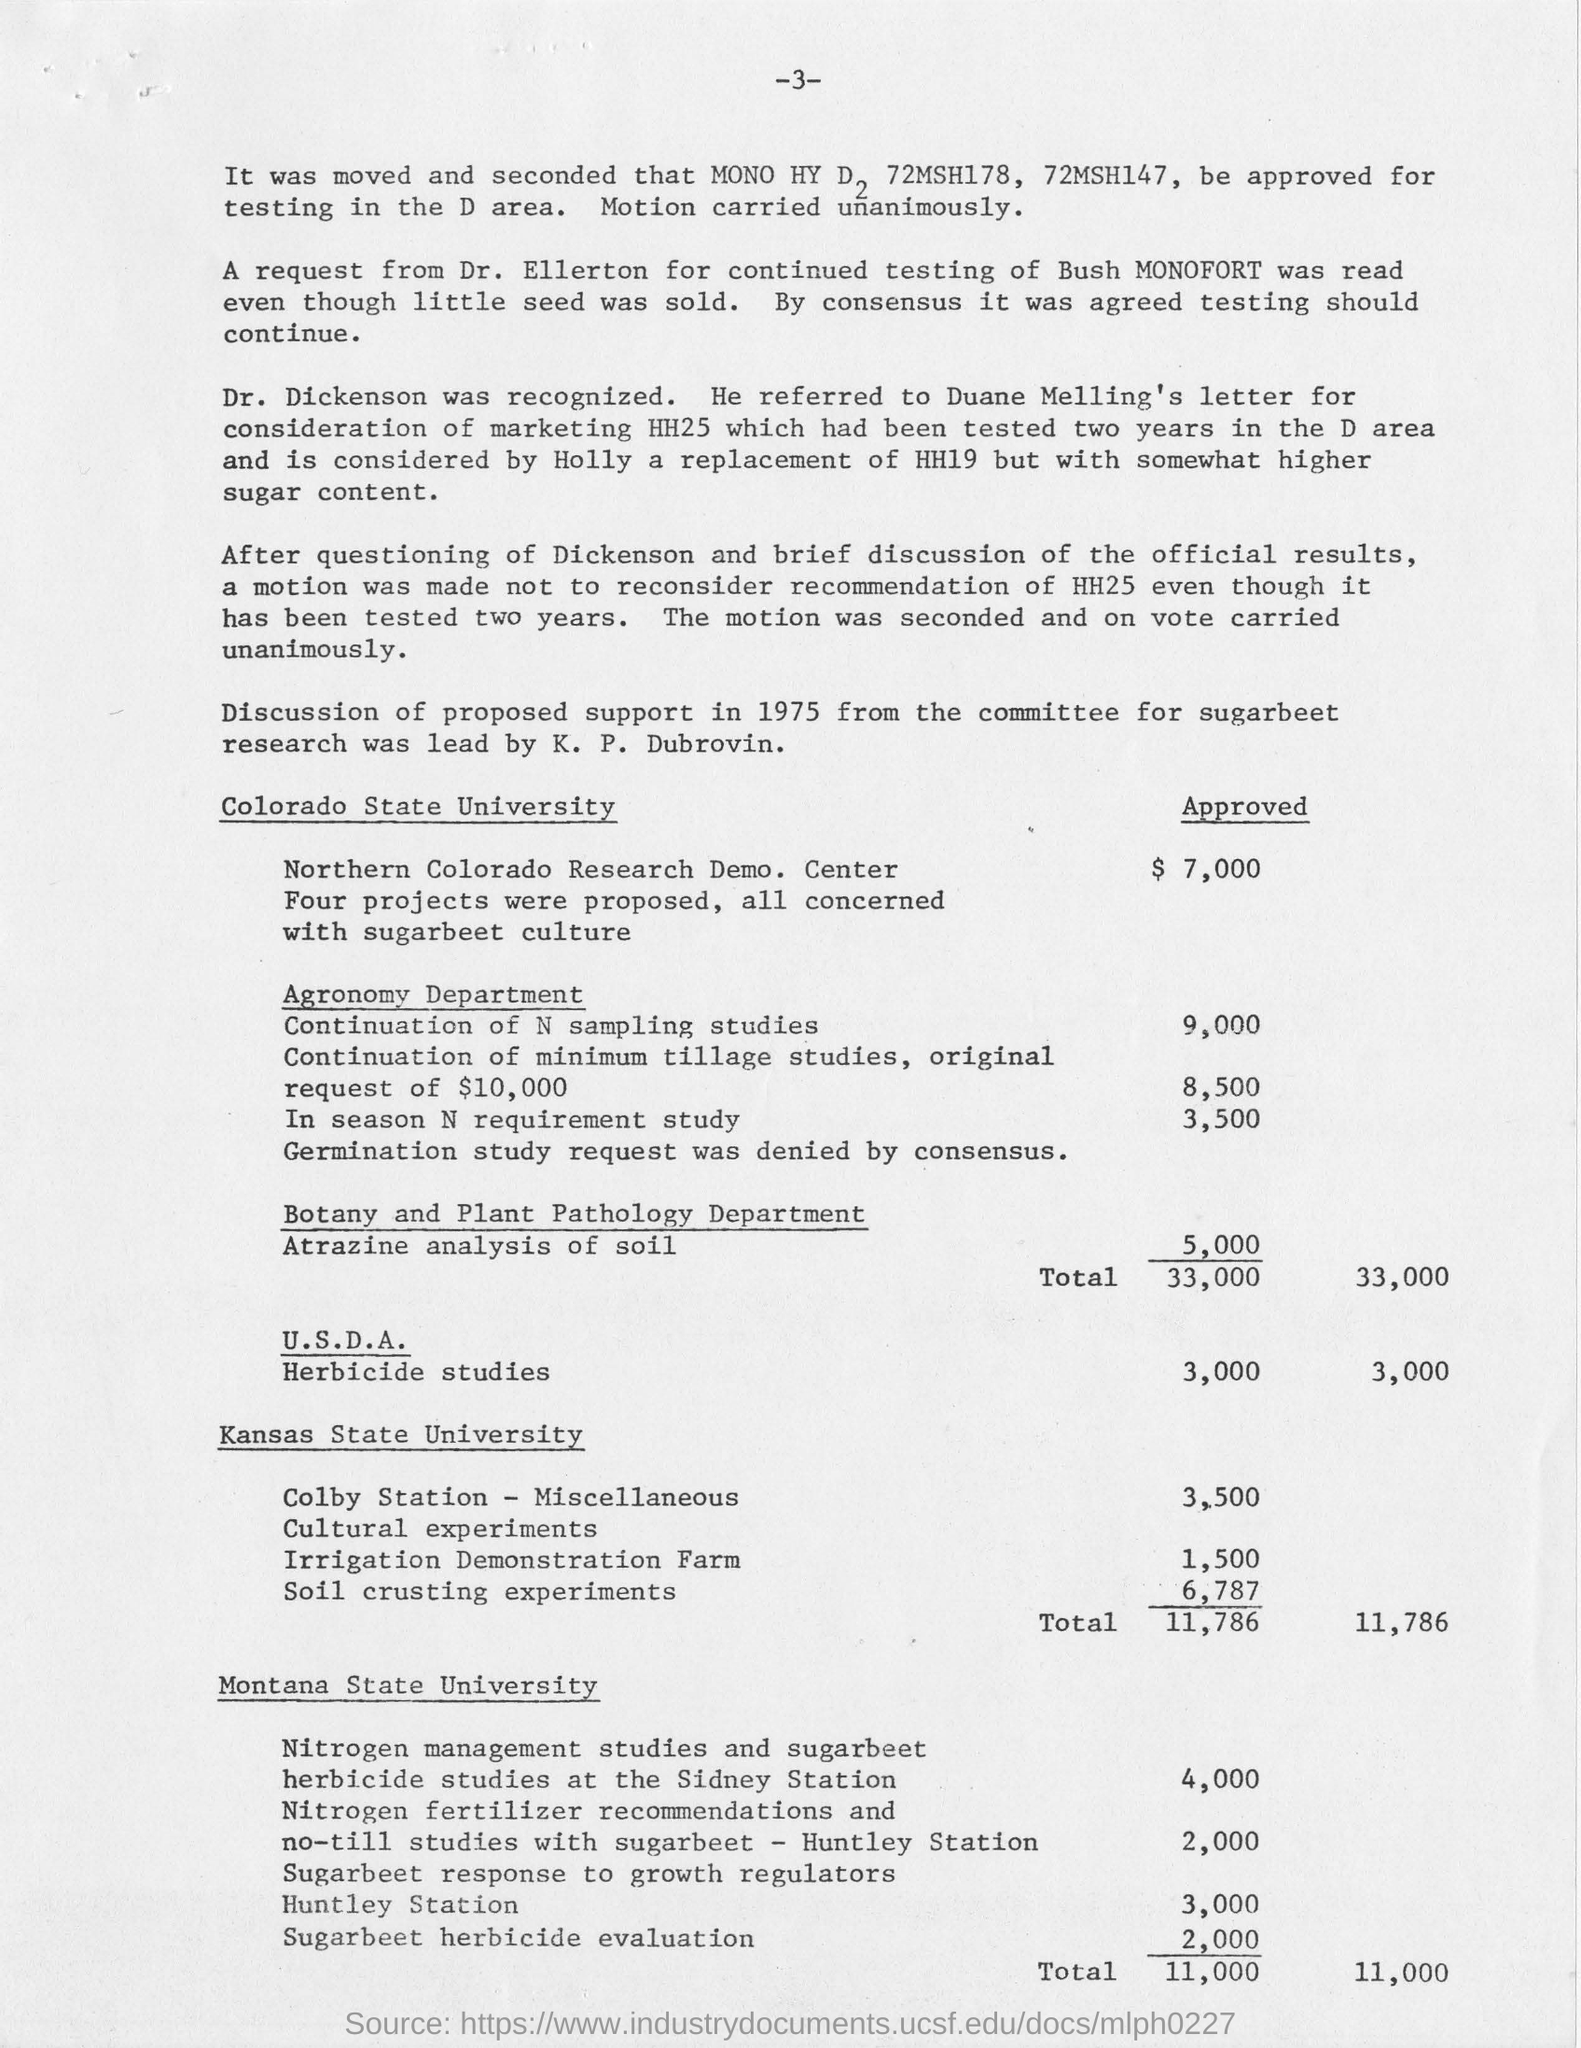Identify some key points in this picture. The approved amount for Herbicide Studies under the U.S. Department of Agriculture (USDA) is $3,000. The leader of the research is K. P. Dubrovin. 